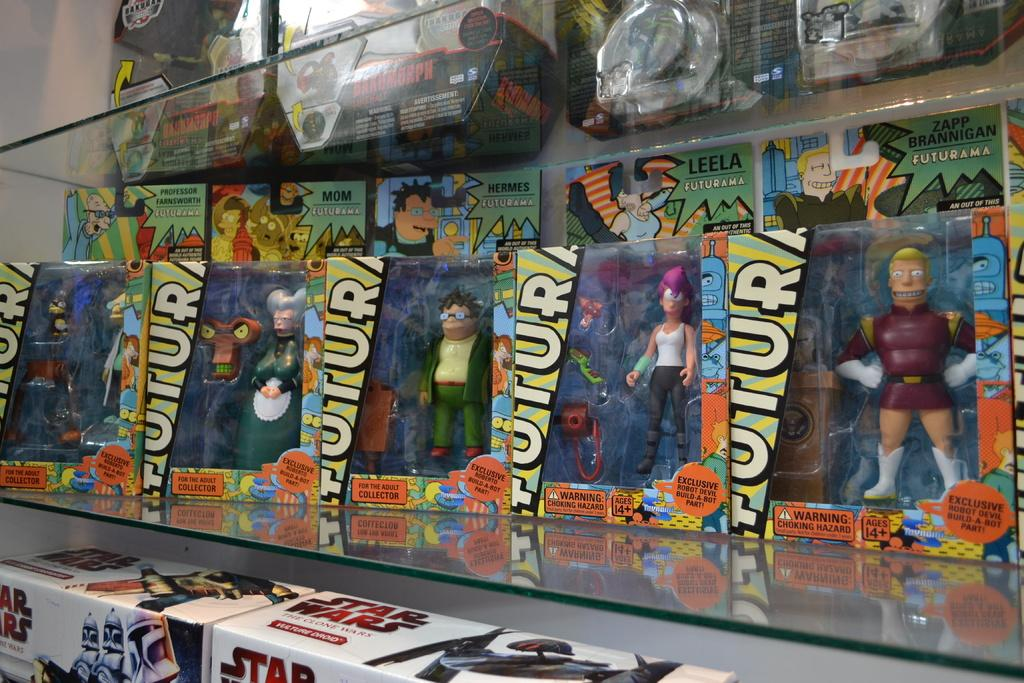Provide a one-sentence caption for the provided image. A row of Futurama action figures are on a toy shelf. 